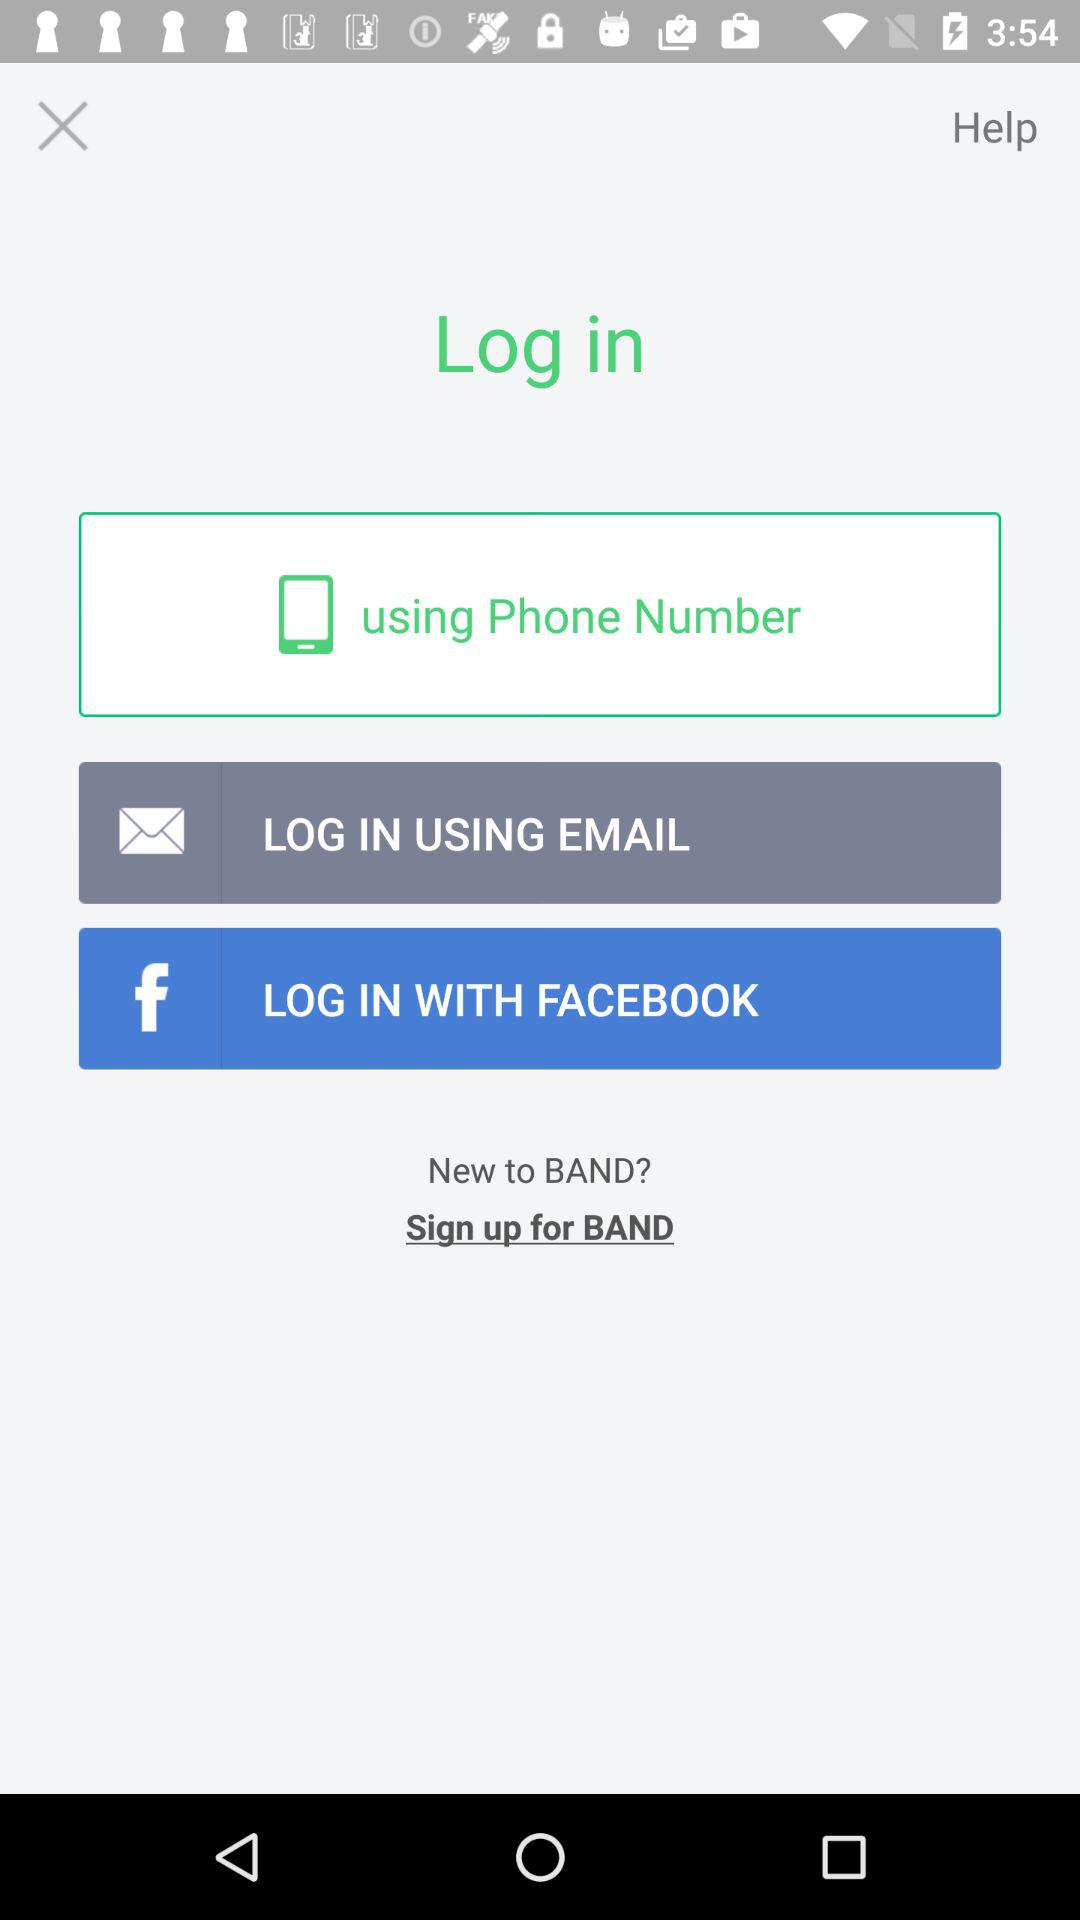With what options can we login? You can login using your "Phone Number", "Email" and "Facebook". 